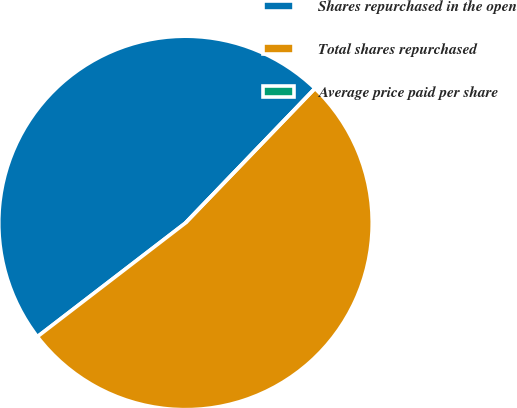Convert chart. <chart><loc_0><loc_0><loc_500><loc_500><pie_chart><fcel>Shares repurchased in the open<fcel>Total shares repurchased<fcel>Average price paid per share<nl><fcel>47.62%<fcel>52.38%<fcel>0.0%<nl></chart> 